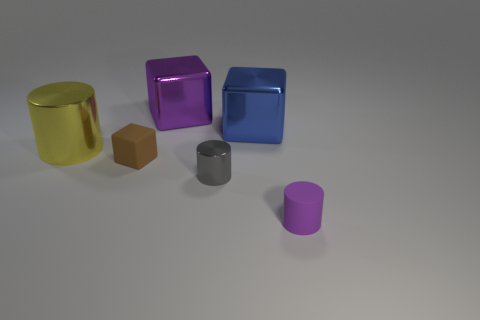How many things are either metal cylinders on the right side of the large cylinder or small brown matte objects?
Ensure brevity in your answer.  2. There is a large block to the left of the gray shiny thing; is its color the same as the rubber cylinder?
Provide a short and direct response. Yes. What size is the yellow metallic thing that is the same shape as the tiny gray object?
Your answer should be compact. Large. The shiny object that is to the left of the tiny brown cube that is in front of the metal thing behind the large blue thing is what color?
Make the answer very short. Yellow. Does the large blue cube have the same material as the purple block?
Give a very brief answer. Yes. Is there a gray cylinder right of the tiny object behind the tiny cylinder left of the purple rubber object?
Offer a terse response. Yes. Are there fewer metal cylinders than small things?
Your answer should be very brief. Yes. Is the large block that is on the right side of the tiny gray metal cylinder made of the same material as the purple object that is behind the large yellow metal object?
Your answer should be very brief. Yes. Is the number of shiny cylinders that are to the right of the brown rubber cube less than the number of purple matte things?
Your response must be concise. No. There is a tiny rubber thing that is in front of the small brown rubber thing; what number of metal blocks are behind it?
Provide a succinct answer. 2. 